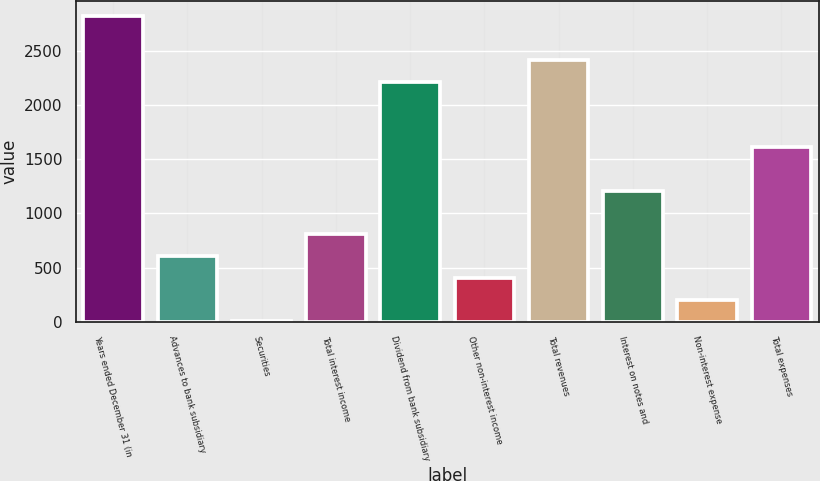Convert chart to OTSL. <chart><loc_0><loc_0><loc_500><loc_500><bar_chart><fcel>Years ended December 31 (in<fcel>Advances to bank subsidiary<fcel>Securities<fcel>Total interest income<fcel>Dividend from bank subsidiary<fcel>Other non-interest income<fcel>Total revenues<fcel>Interest on notes and<fcel>Non-interest expense<fcel>Total expenses<nl><fcel>2820.56<fcel>605.27<fcel>1.1<fcel>806.66<fcel>2216.39<fcel>403.88<fcel>2417.78<fcel>1209.44<fcel>202.49<fcel>1612.22<nl></chart> 